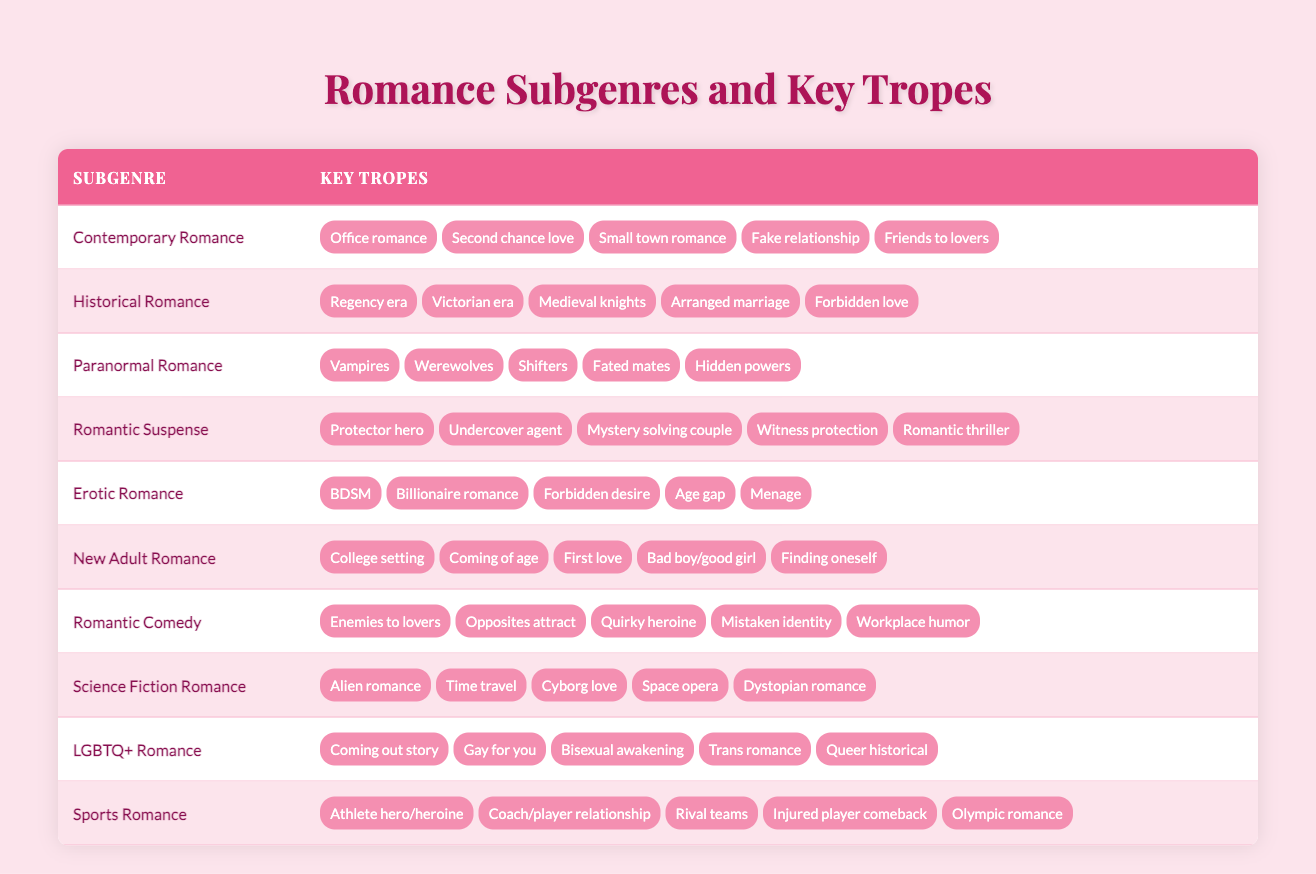What are the key tropes of Contemporary Romance? The table lists the key tropes for Contemporary Romance as: Office romance, Second chance love, Small town romance, Fake relationship, and Friends to lovers.
Answer: Office romance, Second chance love, Small town romance, Fake relationship, Friends to lovers Does Paranormal Romance include shifters as a trope? Yes, shifters are listed as one of the key tropes in the Paranormal Romance subgenre in the table.
Answer: Yes How many key tropes are there in Science Fiction Romance? The table shows that Science Fiction Romance has five key tropes: Alien romance, Time travel, Cyborg love, Space opera, and Dystopian romance. Therefore, the total number is 5.
Answer: 5 Which subgenre has the "Enemies to lovers" trope? The "Enemies to lovers" trope is found under the Romantic Comedy subgenre in the table, indicating that this is a key trope associated with that category.
Answer: Romantic Comedy Are there any tropes in Historical Romance that involve love's challenges? Yes, among the key tropes listed for Historical Romance, "Forbidden love" clearly represents a challenge in romantic relationships, demonstrating a significant barrier for characters in that genre.
Answer: Yes What is the fifth trope listed in Erotic Romance? The fifth trope listed for Erotic Romance in the table is "Menage." This specific detail indicates the various types of romantic themes within that subgenre.
Answer: Menage What is the difference in the number of tropes between Romantic Suspense and Sports Romance? Both genres have five key tropes each, resulting in no difference; therefore, the difference in the number of tropes is 0.
Answer: 0 Identify a common trope between New Adult Romance and Contemporary Romance. "First love" is a common trope found in both New Adult Romance and Contemporary Romance, indicating similar themes of young adult relationships in these subgenres.
Answer: First love How many tropes related to love's complexity exist in LGBTQ+ Romance? LGBTQ+ Romance includes five key tropes: Coming out story, Gay for you, Bisexual awakening, Trans romance, and Queer historical. None of these explicitly state complexity; however, all encompass different dimensions of love's challenges. There are 5 key tropes.
Answer: 5 